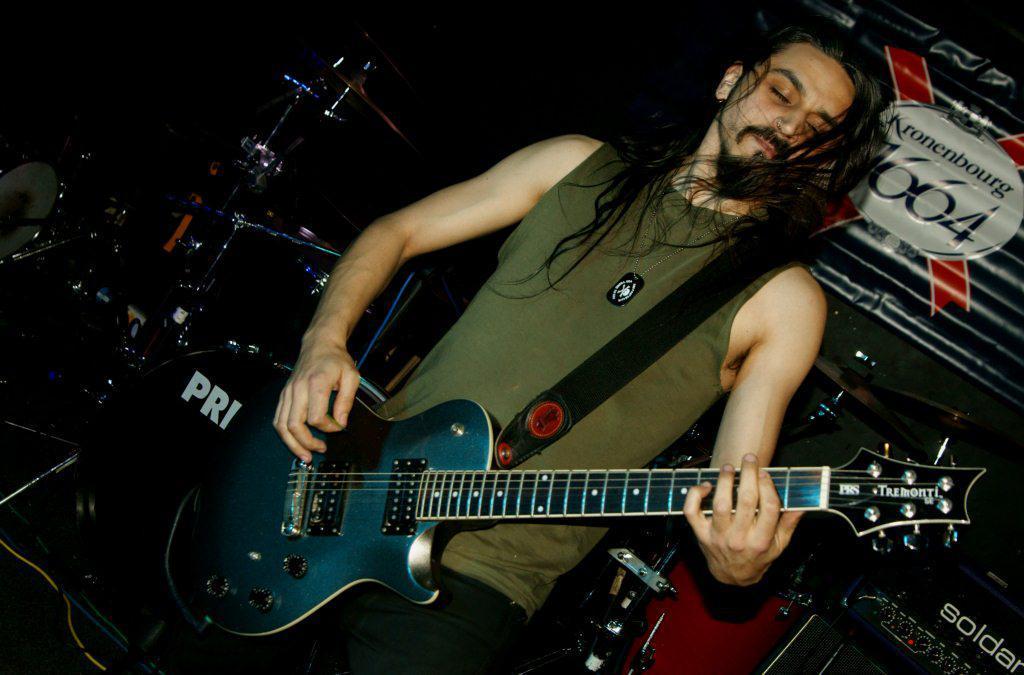In one or two sentences, can you explain what this image depicts? In this image I can see in the middle a man is playing the guitar, he is wearing a t-shirt. There are musical instruments around him. 